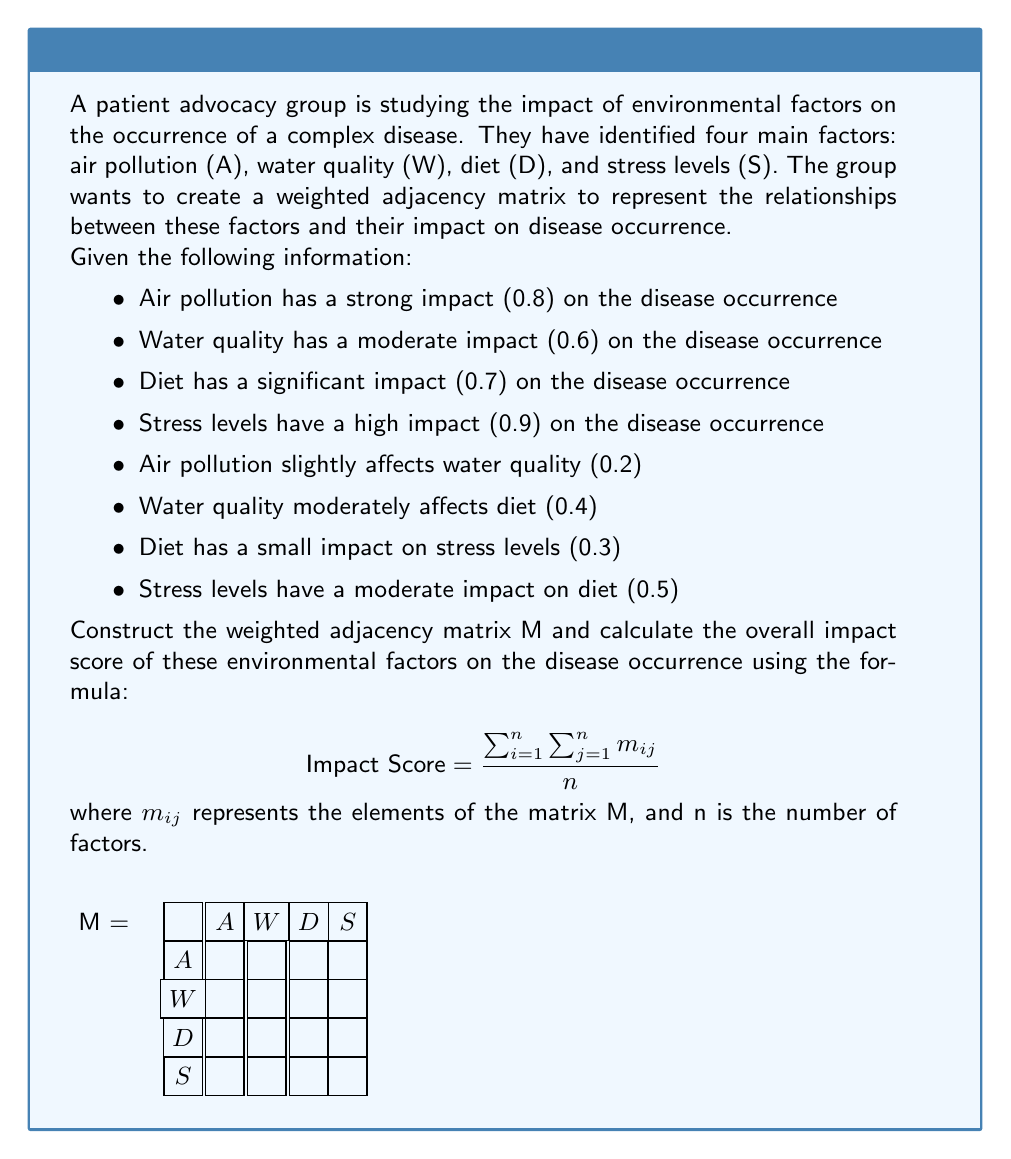Provide a solution to this math problem. Let's approach this step-by-step:

1) First, we need to construct the weighted adjacency matrix M. The rows and columns represent A, W, D, and S in that order. The diagonal elements represent the direct impact of each factor on the disease occurrence.

$$ M = \begin{bmatrix}
0.8 & 0.2 & 0 & 0 \\
0 & 0.6 & 0.4 & 0 \\
0 & 0 & 0.7 & 0.3 \\
0 & 0 & 0.5 & 0.9
\end{bmatrix} $$

2) Now, we need to calculate the impact score using the given formula:

$$ \text{Impact Score} = \frac{\sum_{i=1}^n \sum_{j=1}^n m_{ij}}{n} $$

3) Let's sum all the elements in the matrix:

$$ \sum_{i=1}^n \sum_{j=1}^n m_{ij} = 0.8 + 0.2 + 0.6 + 0.4 + 0.7 + 0.3 + 0.5 + 0.9 = 4.4 $$

4) Now, we divide by n, which is the number of factors (4 in this case):

$$ \text{Impact Score} = \frac{4.4}{4} = 1.1 $$

Therefore, the overall impact score of these environmental factors on the disease occurrence is 1.1.
Answer: 1.1 